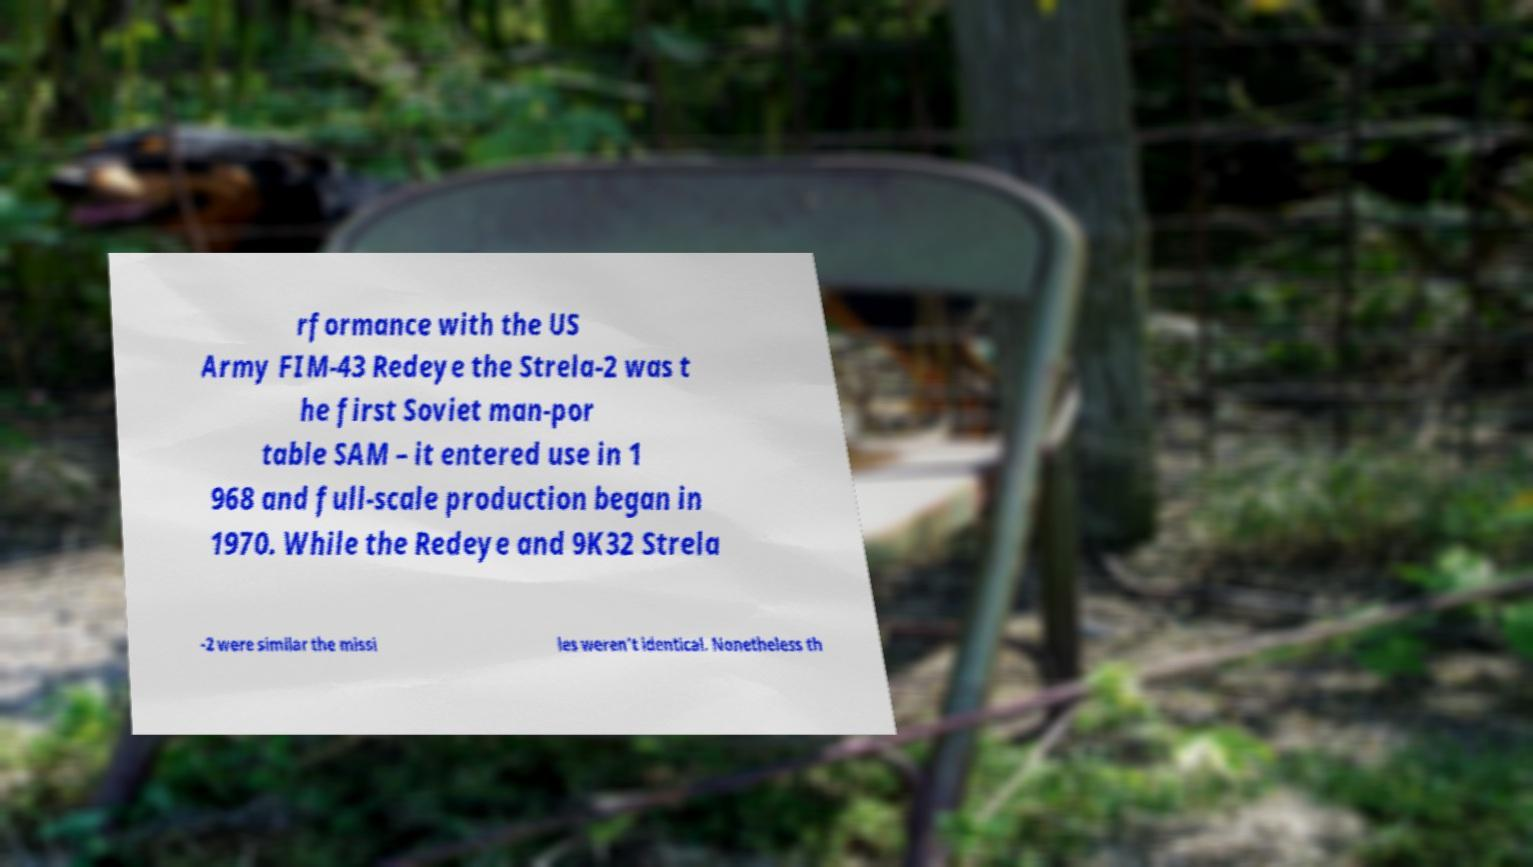I need the written content from this picture converted into text. Can you do that? rformance with the US Army FIM-43 Redeye the Strela-2 was t he first Soviet man-por table SAM – it entered use in 1 968 and full-scale production began in 1970. While the Redeye and 9K32 Strela -2 were similar the missi les weren’t identical. Nonetheless th 